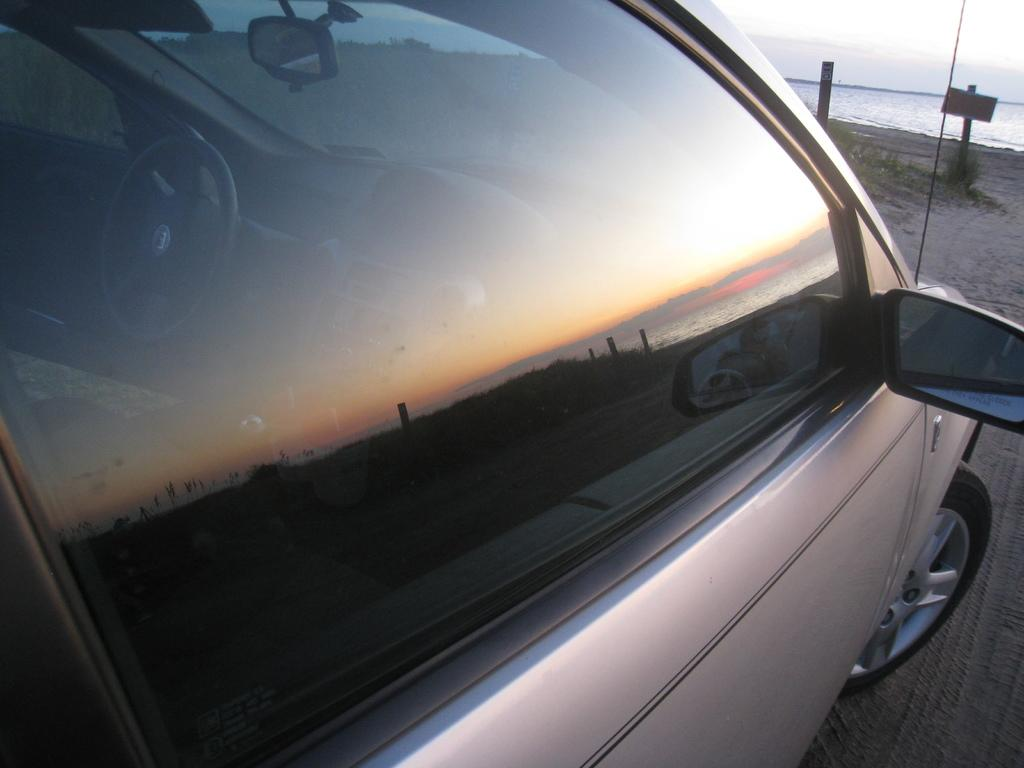What is located at the front of the image? There is a car in the front of the image. What can be seen in the middle of the image? There is a board and grass in the middle of the image. What is visible in the background of the image? Water is visible in the background of the image. What is visible at the top of the image? The sky is visible at the top of the image. What type of arch can be seen in the image? There is no arch present in the image. What kind of toys are scattered around the grass in the image? There are no toys present in the image; it features a car, a board, grass, water, and the sky. 